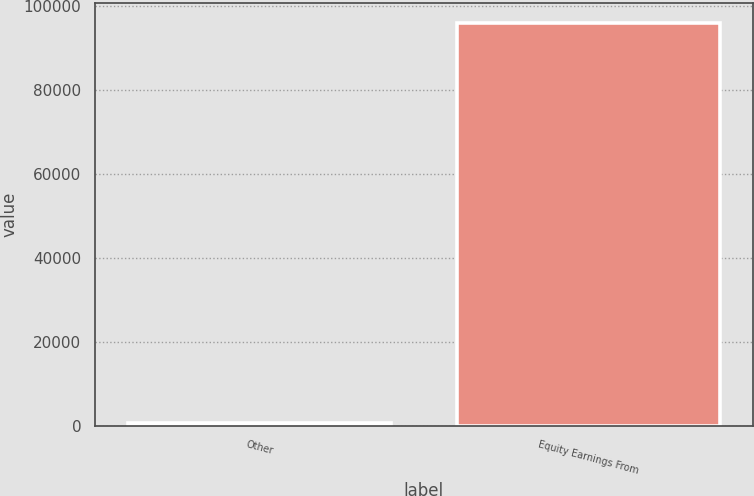<chart> <loc_0><loc_0><loc_500><loc_500><bar_chart><fcel>Other<fcel>Equity Earnings From<nl><fcel>874<fcel>95883<nl></chart> 